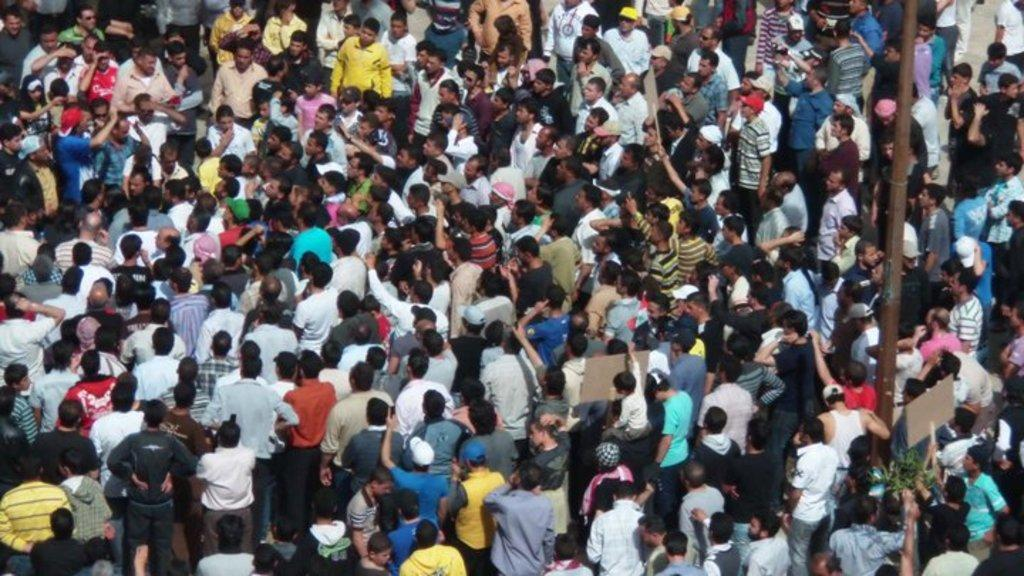What is present in the image? There are people in the image. What are some of the people doing in the image? Some of the people are holding placards. Can you describe any other objects or structures in the image? Yes, there is a pole in the image. Can you see any hills or volcanoes in the image? There are no hills or volcanoes present in the image. Are there any dolls visible in the image? There are no dolls present in the image. 